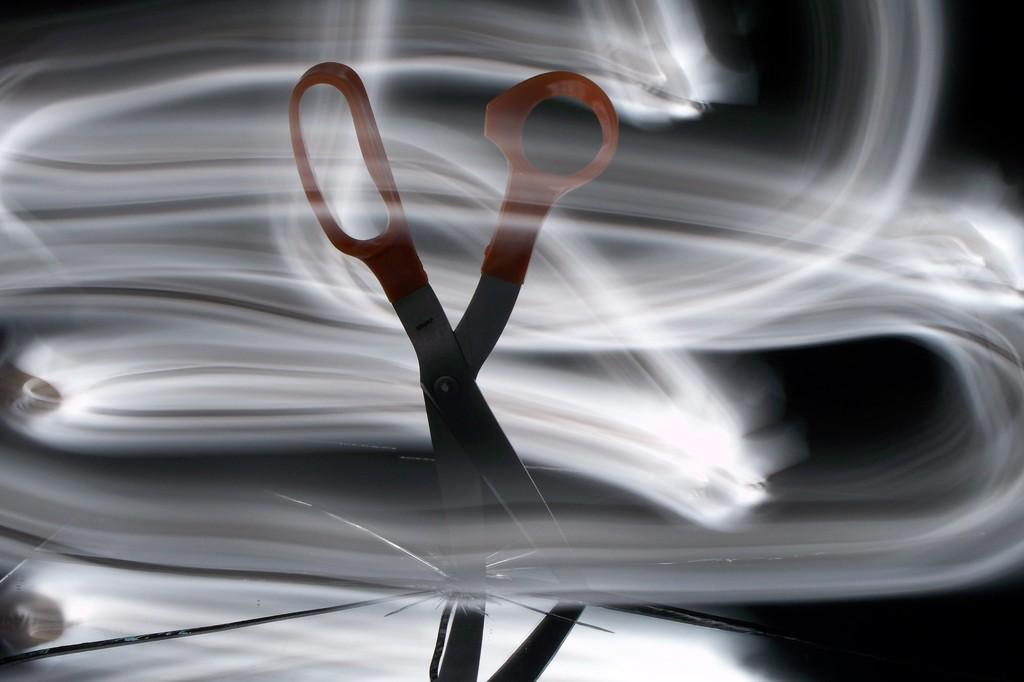What color is the scissor in the image? The scissor in the image is orange-colored. How many tigers can be seen playing with the scissor in the image? There are no tigers present in the image, and therefore no such activity can be observed. 